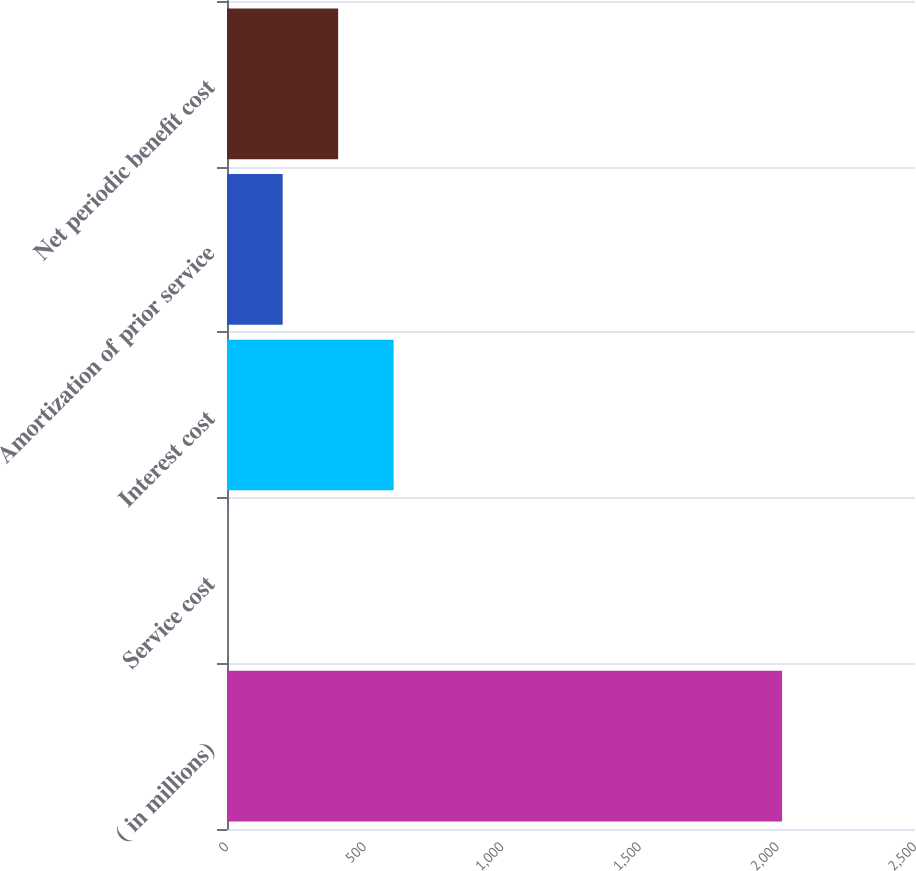Convert chart to OTSL. <chart><loc_0><loc_0><loc_500><loc_500><bar_chart><fcel>( in millions)<fcel>Service cost<fcel>Interest cost<fcel>Amortization of prior service<fcel>Net periodic benefit cost<nl><fcel>2017<fcel>0.7<fcel>605.59<fcel>202.33<fcel>403.96<nl></chart> 